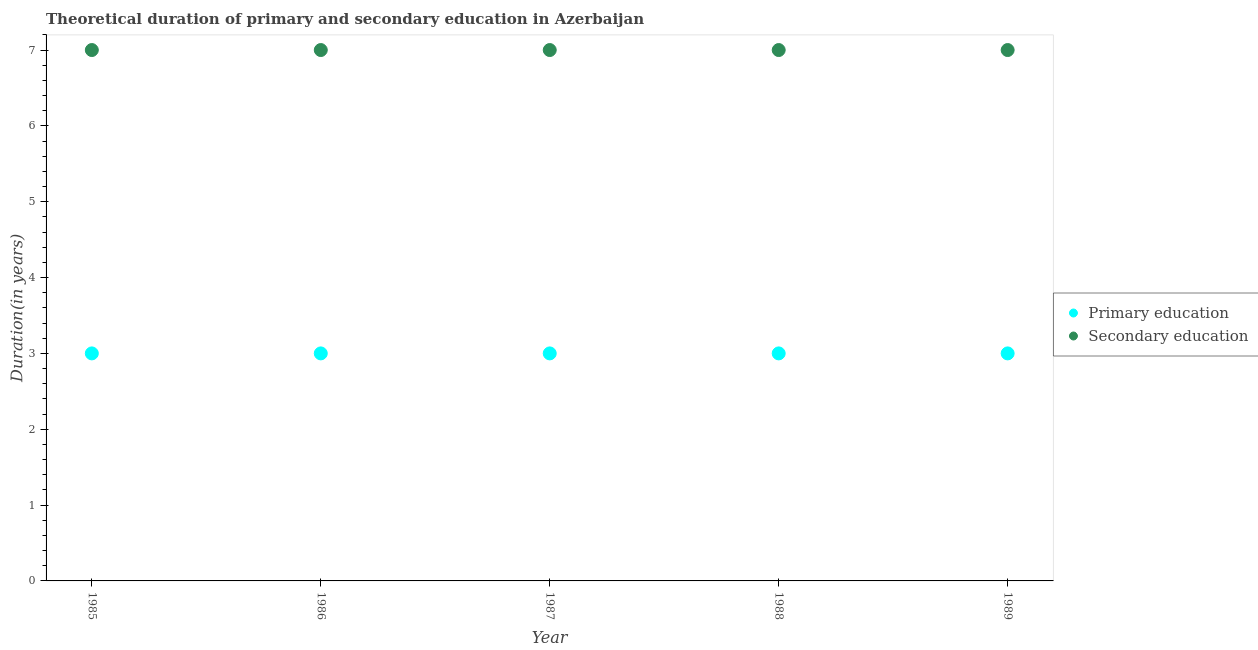What is the duration of primary education in 1986?
Your response must be concise. 3. Across all years, what is the maximum duration of primary education?
Your answer should be compact. 3. Across all years, what is the minimum duration of secondary education?
Offer a very short reply. 7. What is the total duration of primary education in the graph?
Your response must be concise. 15. What is the difference between the duration of primary education in 1987 and that in 1989?
Offer a very short reply. 0. What is the difference between the duration of secondary education in 1989 and the duration of primary education in 1986?
Keep it short and to the point. 4. What is the average duration of primary education per year?
Provide a short and direct response. 3. In the year 1985, what is the difference between the duration of secondary education and duration of primary education?
Keep it short and to the point. 4. In how many years, is the duration of secondary education greater than 2 years?
Make the answer very short. 5. Is the difference between the duration of primary education in 1987 and 1989 greater than the difference between the duration of secondary education in 1987 and 1989?
Ensure brevity in your answer.  No. What is the difference between the highest and the second highest duration of primary education?
Offer a terse response. 0. Is the sum of the duration of secondary education in 1985 and 1986 greater than the maximum duration of primary education across all years?
Offer a terse response. Yes. Is the duration of secondary education strictly greater than the duration of primary education over the years?
Give a very brief answer. Yes. How many dotlines are there?
Ensure brevity in your answer.  2. Are the values on the major ticks of Y-axis written in scientific E-notation?
Offer a very short reply. No. Does the graph contain any zero values?
Provide a succinct answer. No. Where does the legend appear in the graph?
Your answer should be very brief. Center right. What is the title of the graph?
Offer a very short reply. Theoretical duration of primary and secondary education in Azerbaijan. What is the label or title of the Y-axis?
Provide a short and direct response. Duration(in years). What is the Duration(in years) of Primary education in 1985?
Make the answer very short. 3. What is the Duration(in years) of Secondary education in 1985?
Provide a succinct answer. 7. What is the Duration(in years) in Primary education in 1986?
Provide a succinct answer. 3. Across all years, what is the maximum Duration(in years) of Secondary education?
Your answer should be very brief. 7. Across all years, what is the minimum Duration(in years) of Primary education?
Keep it short and to the point. 3. What is the difference between the Duration(in years) of Primary education in 1985 and that in 1986?
Make the answer very short. 0. What is the difference between the Duration(in years) in Secondary education in 1985 and that in 1986?
Give a very brief answer. 0. What is the difference between the Duration(in years) of Secondary education in 1985 and that in 1987?
Your answer should be very brief. 0. What is the difference between the Duration(in years) of Primary education in 1985 and that in 1988?
Provide a short and direct response. 0. What is the difference between the Duration(in years) in Primary education in 1985 and that in 1989?
Offer a terse response. 0. What is the difference between the Duration(in years) in Secondary education in 1985 and that in 1989?
Ensure brevity in your answer.  0. What is the difference between the Duration(in years) of Primary education in 1986 and that in 1987?
Provide a short and direct response. 0. What is the difference between the Duration(in years) in Secondary education in 1986 and that in 1989?
Provide a short and direct response. 0. What is the difference between the Duration(in years) of Primary education in 1987 and that in 1988?
Your response must be concise. 0. What is the difference between the Duration(in years) of Primary education in 1987 and that in 1989?
Provide a short and direct response. 0. What is the difference between the Duration(in years) in Secondary education in 1987 and that in 1989?
Offer a very short reply. 0. What is the difference between the Duration(in years) in Primary education in 1985 and the Duration(in years) in Secondary education in 1988?
Ensure brevity in your answer.  -4. What is the difference between the Duration(in years) in Primary education in 1985 and the Duration(in years) in Secondary education in 1989?
Offer a terse response. -4. What is the difference between the Duration(in years) of Primary education in 1987 and the Duration(in years) of Secondary education in 1989?
Offer a terse response. -4. What is the difference between the Duration(in years) of Primary education in 1988 and the Duration(in years) of Secondary education in 1989?
Provide a short and direct response. -4. What is the average Duration(in years) of Secondary education per year?
Your answer should be compact. 7. What is the ratio of the Duration(in years) of Primary education in 1985 to that in 1986?
Your answer should be compact. 1. What is the ratio of the Duration(in years) in Primary education in 1985 to that in 1987?
Ensure brevity in your answer.  1. What is the ratio of the Duration(in years) in Secondary education in 1985 to that in 1987?
Provide a succinct answer. 1. What is the ratio of the Duration(in years) of Secondary education in 1985 to that in 1989?
Provide a succinct answer. 1. What is the ratio of the Duration(in years) of Primary education in 1986 to that in 1987?
Offer a very short reply. 1. What is the ratio of the Duration(in years) in Primary education in 1986 to that in 1989?
Give a very brief answer. 1. What is the ratio of the Duration(in years) in Primary education in 1987 to that in 1989?
Provide a short and direct response. 1. What is the difference between the highest and the second highest Duration(in years) of Secondary education?
Offer a very short reply. 0. What is the difference between the highest and the lowest Duration(in years) in Secondary education?
Provide a short and direct response. 0. 